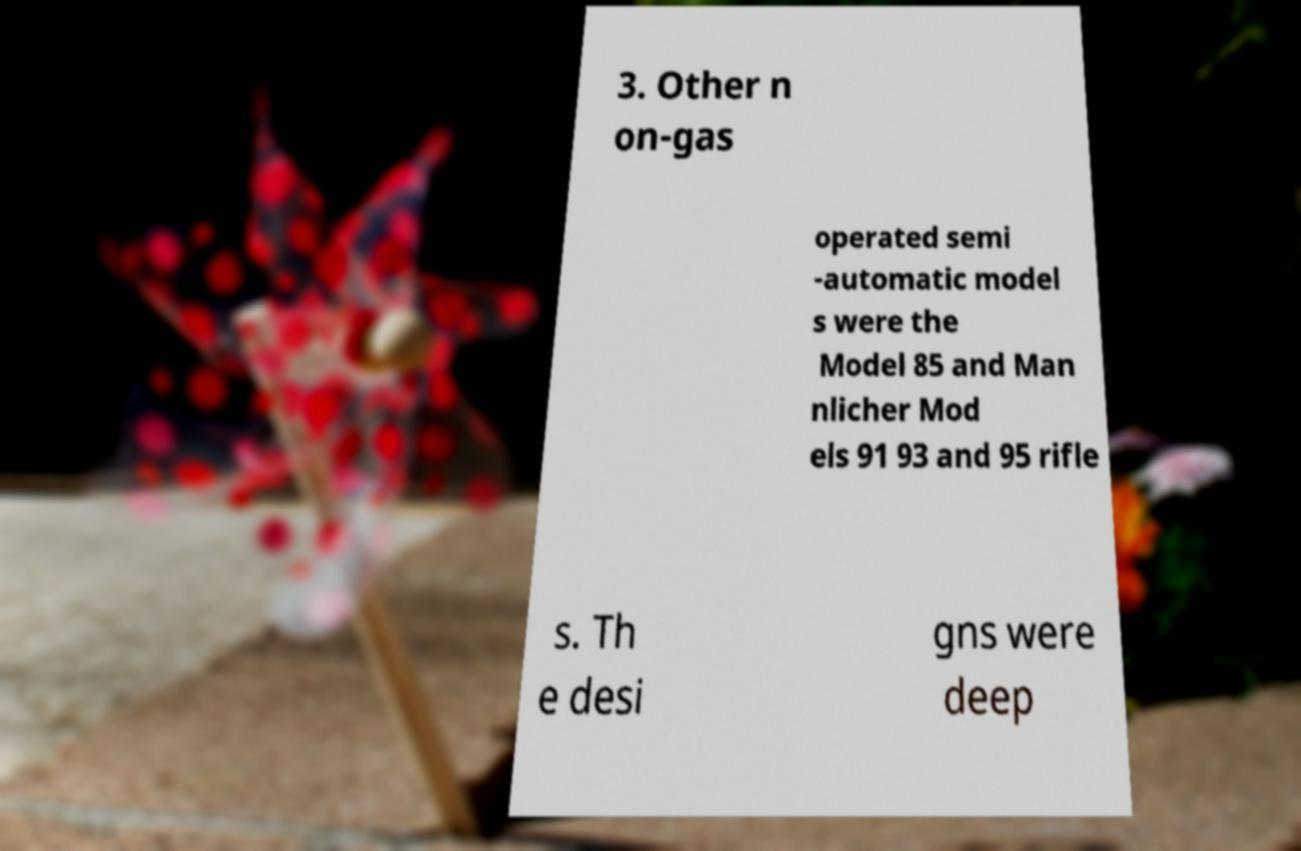Please read and relay the text visible in this image. What does it say? 3. Other n on-gas operated semi -automatic model s were the Model 85 and Man nlicher Mod els 91 93 and 95 rifle s. Th e desi gns were deep 